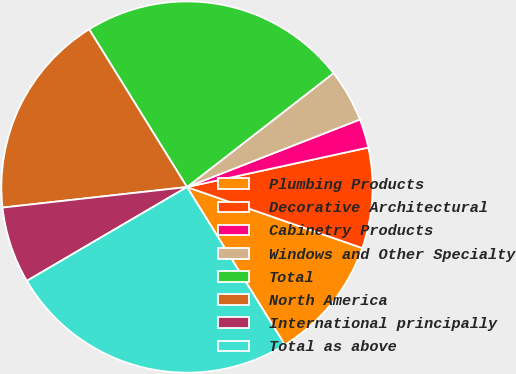Convert chart. <chart><loc_0><loc_0><loc_500><loc_500><pie_chart><fcel>Plumbing Products<fcel>Decorative Architectural<fcel>Cabinetry Products<fcel>Windows and Other Specialty<fcel>Total<fcel>North America<fcel>International principally<fcel>Total as above<nl><fcel>10.83%<fcel>8.75%<fcel>2.51%<fcel>4.59%<fcel>23.32%<fcel>17.93%<fcel>6.67%<fcel>25.4%<nl></chart> 